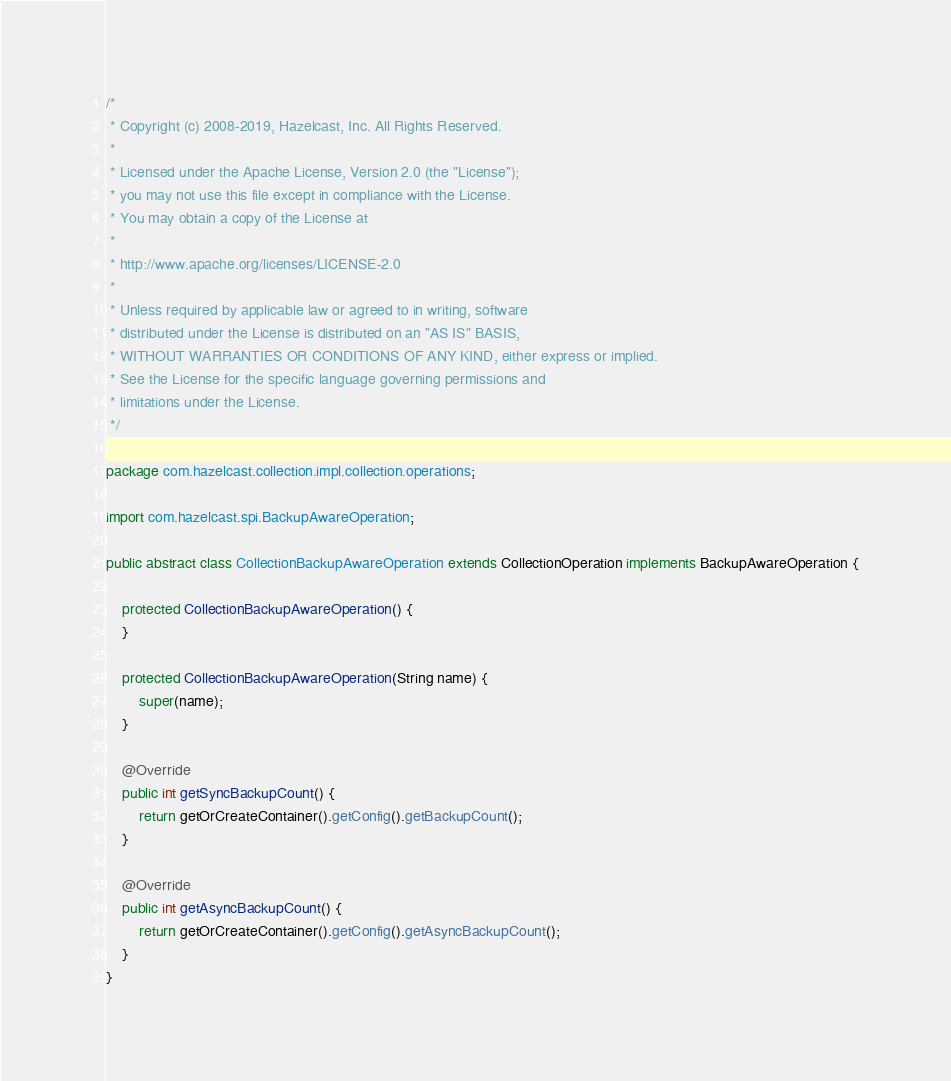Convert code to text. <code><loc_0><loc_0><loc_500><loc_500><_Java_>/*
 * Copyright (c) 2008-2019, Hazelcast, Inc. All Rights Reserved.
 *
 * Licensed under the Apache License, Version 2.0 (the "License");
 * you may not use this file except in compliance with the License.
 * You may obtain a copy of the License at
 *
 * http://www.apache.org/licenses/LICENSE-2.0
 *
 * Unless required by applicable law or agreed to in writing, software
 * distributed under the License is distributed on an "AS IS" BASIS,
 * WITHOUT WARRANTIES OR CONDITIONS OF ANY KIND, either express or implied.
 * See the License for the specific language governing permissions and
 * limitations under the License.
 */

package com.hazelcast.collection.impl.collection.operations;

import com.hazelcast.spi.BackupAwareOperation;

public abstract class CollectionBackupAwareOperation extends CollectionOperation implements BackupAwareOperation {

    protected CollectionBackupAwareOperation() {
    }

    protected CollectionBackupAwareOperation(String name) {
        super(name);
    }

    @Override
    public int getSyncBackupCount() {
        return getOrCreateContainer().getConfig().getBackupCount();
    }

    @Override
    public int getAsyncBackupCount() {
        return getOrCreateContainer().getConfig().getAsyncBackupCount();
    }
}
</code> 